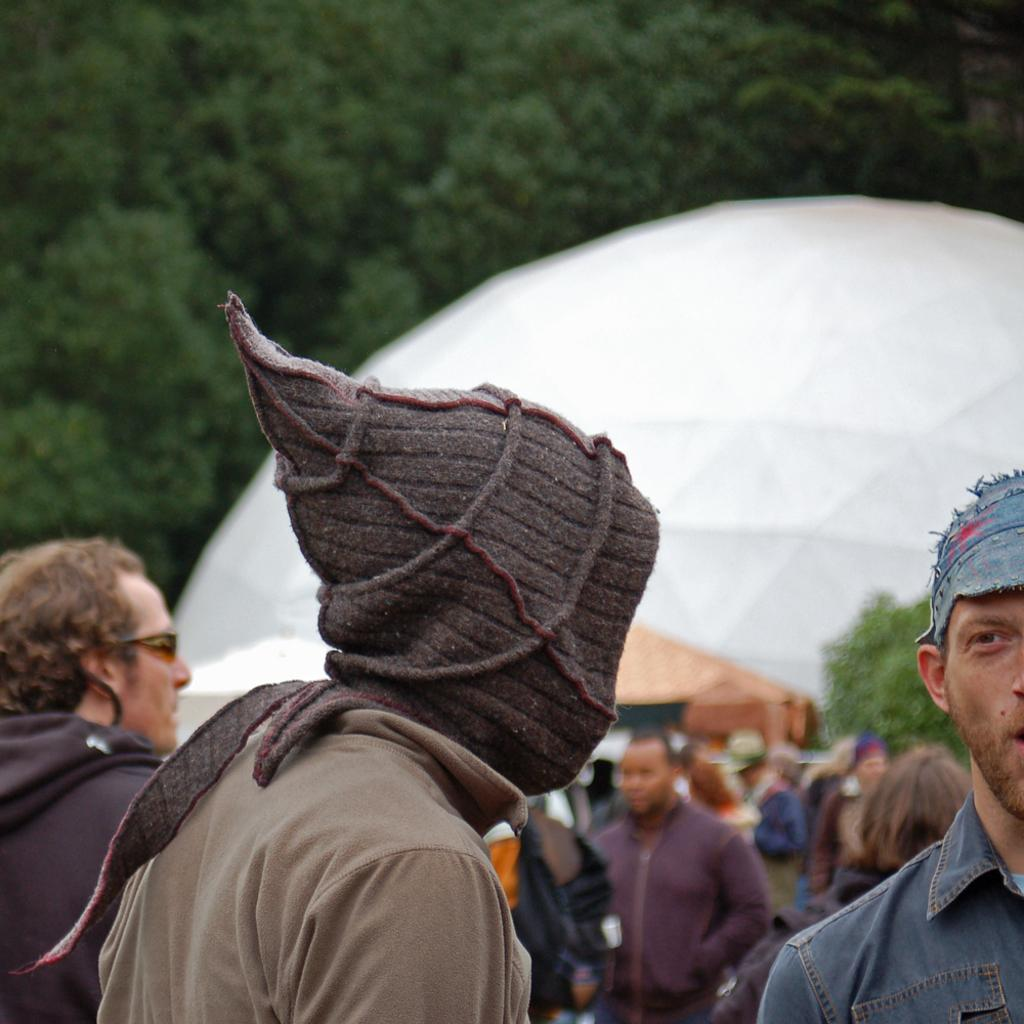How many people are in the group in the image? There is a group of people in the image, but the exact number cannot be determined from the provided facts. What are some people in the group wearing? Some people in the group are wearing caps. What can be said about the background of the image? The background of the image is blurred. What is the color of the white object in the image? The color of the white object in the image cannot be determined from the provided facts. What type of vegetation is present in the image? Trees are present in the image. What type of cushion is being used by the person sitting on the suit in the image? There is no person sitting on a suit in the image, nor is there a cushion present. 